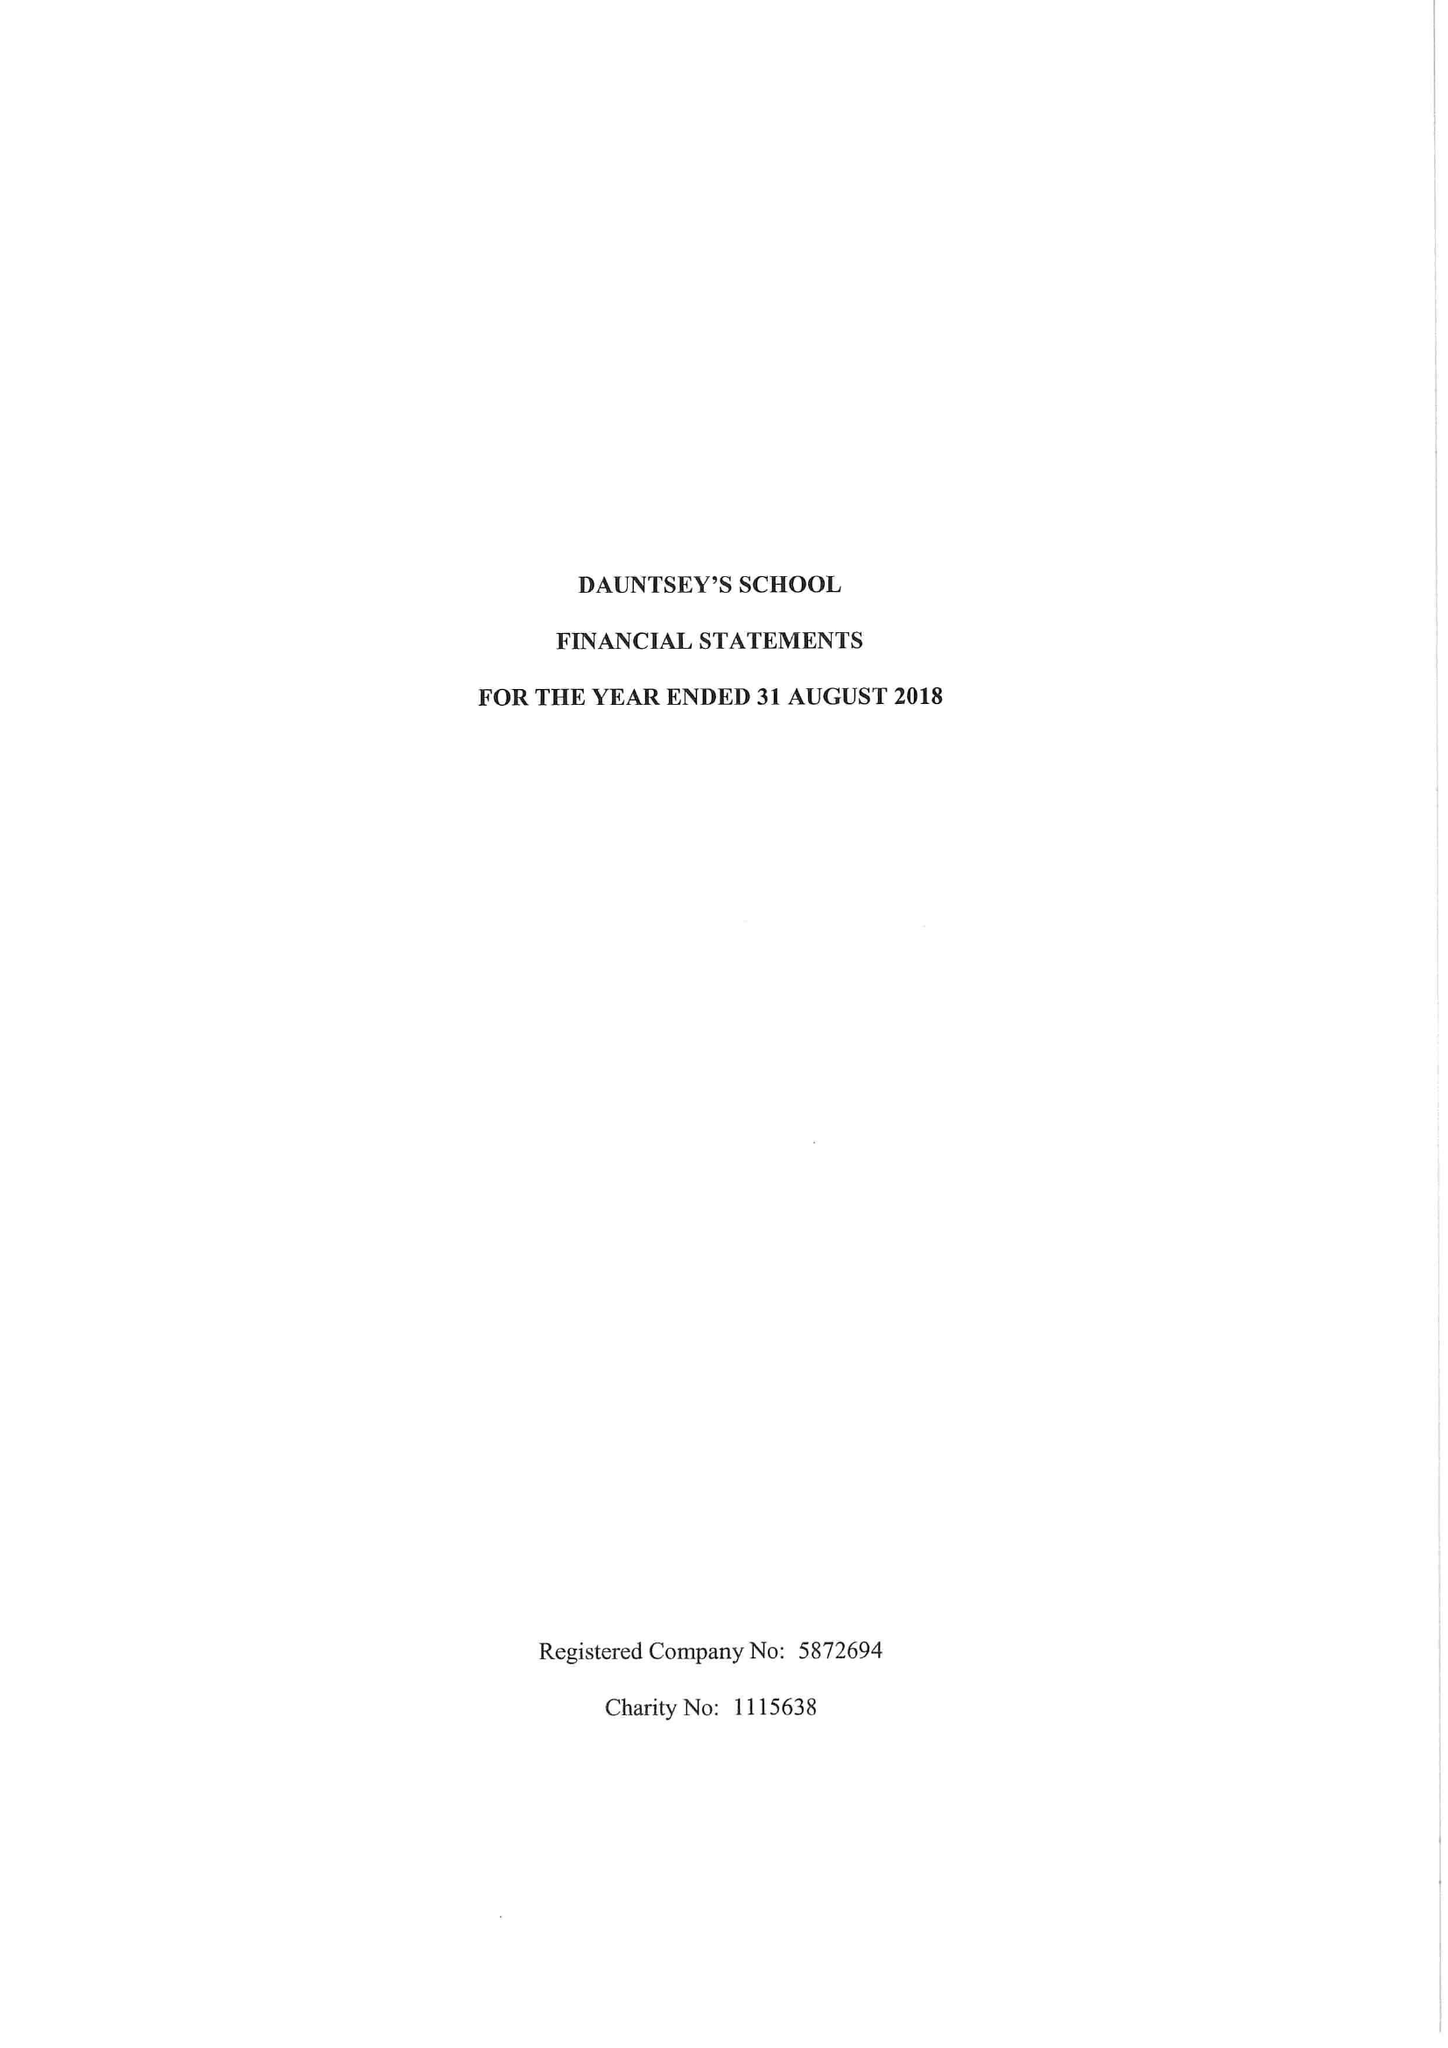What is the value for the spending_annually_in_british_pounds?
Answer the question using a single word or phrase. 17351604.00 